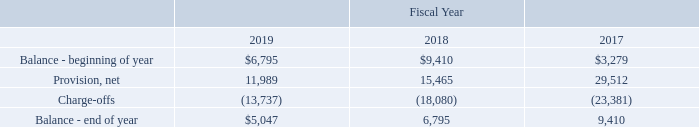7. ACCOUNTS RECEIVABLES ALLOWANCES
Summarized below is the activity in our accounts receivable allowances including compensation credits and doubtful accounts as follows (in thousands):
The balances at the end of fiscal years 2019, 2018 and 2017 are comprised primarily of compensation credits of $4.5 million, $6.3 million and $8.9 million, respectively.
What were the respective balances at the end of 2019, 2018 and 2017? $4.5 million, $6.3 million, $8.9 million. What was the respective value of Provision, net in 2019 and 2018?
Answer scale should be: thousand. 11,989, 15,465. What was the charge-offs in 2019?
Answer scale should be: thousand. (13,737). What was the change in the Balance - beginning of year from 2018 to 2019?
Answer scale should be: thousand. 6,795 - 9,410
Answer: -2615. What was the average Provision, net for 2017-2019?
Answer scale should be: thousand. (11,989 + 15,465 + 29,512) / 3
Answer: 18988.67. In which year was Balance - end of year less than 7,000 thousands? Locate and analyze balance - end of year in row 6
answer: 2019, 2018. 